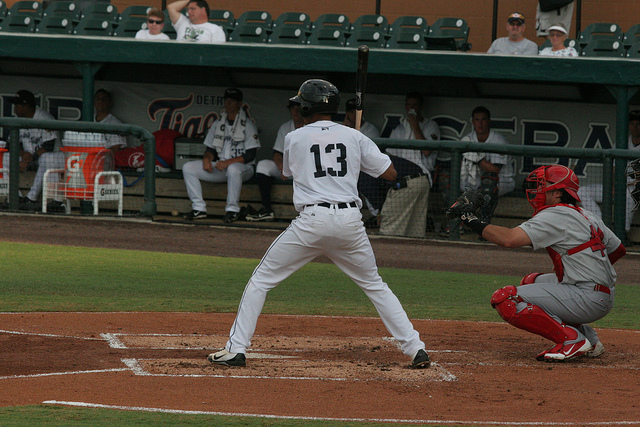Read all the text in this image. DETR 13 